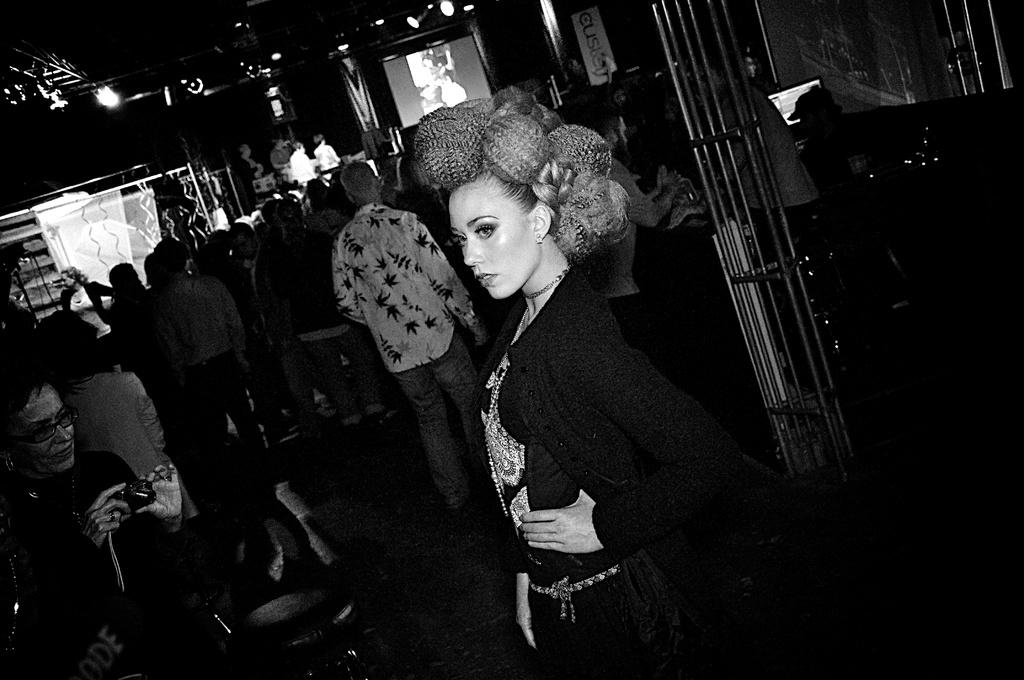What is the color scheme of the image? The image is black and white. Who or what can be seen in the image? There are people in the image. What objects are present in the image? There are rods, screens, focusing lights, a banner, and other objects in the image. What is the woman in the front of the image holding? The woman is holding a camera in the front of the image. What type of scent can be detected from the harbor in the image? There is no harbor present in the image, so there is no scent to detect. What type of spark can be seen in the image? There is no spark visible in the image. 